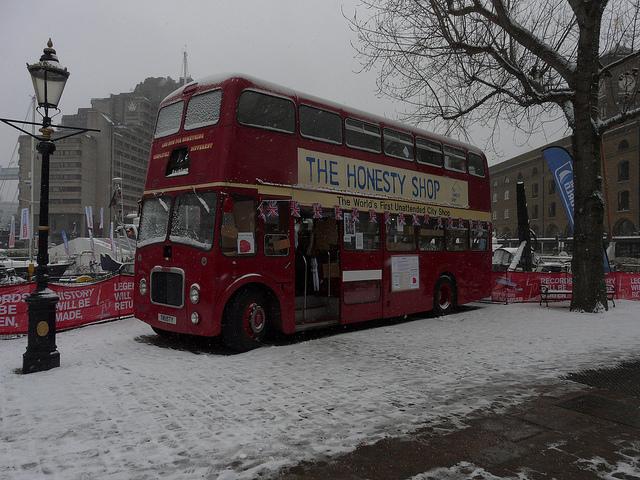What color is the bus?
Be succinct. Red. What city was this taken in?
Answer briefly. London. Is it sunny?
Write a very short answer. No. What banner is on the top deck of the bus?
Quick response, please. Honesty shop. Where is the bus?
Short answer required. Street. What is the object sitting behind the pile of snow?
Short answer required. Bus. On what social networks can this food truck be found?
Answer briefly. Facebook. What is in front of the bus?
Give a very brief answer. Light pole. Was the picture taken in Summer?
Answer briefly. No. Where is this?
Be succinct. England. 